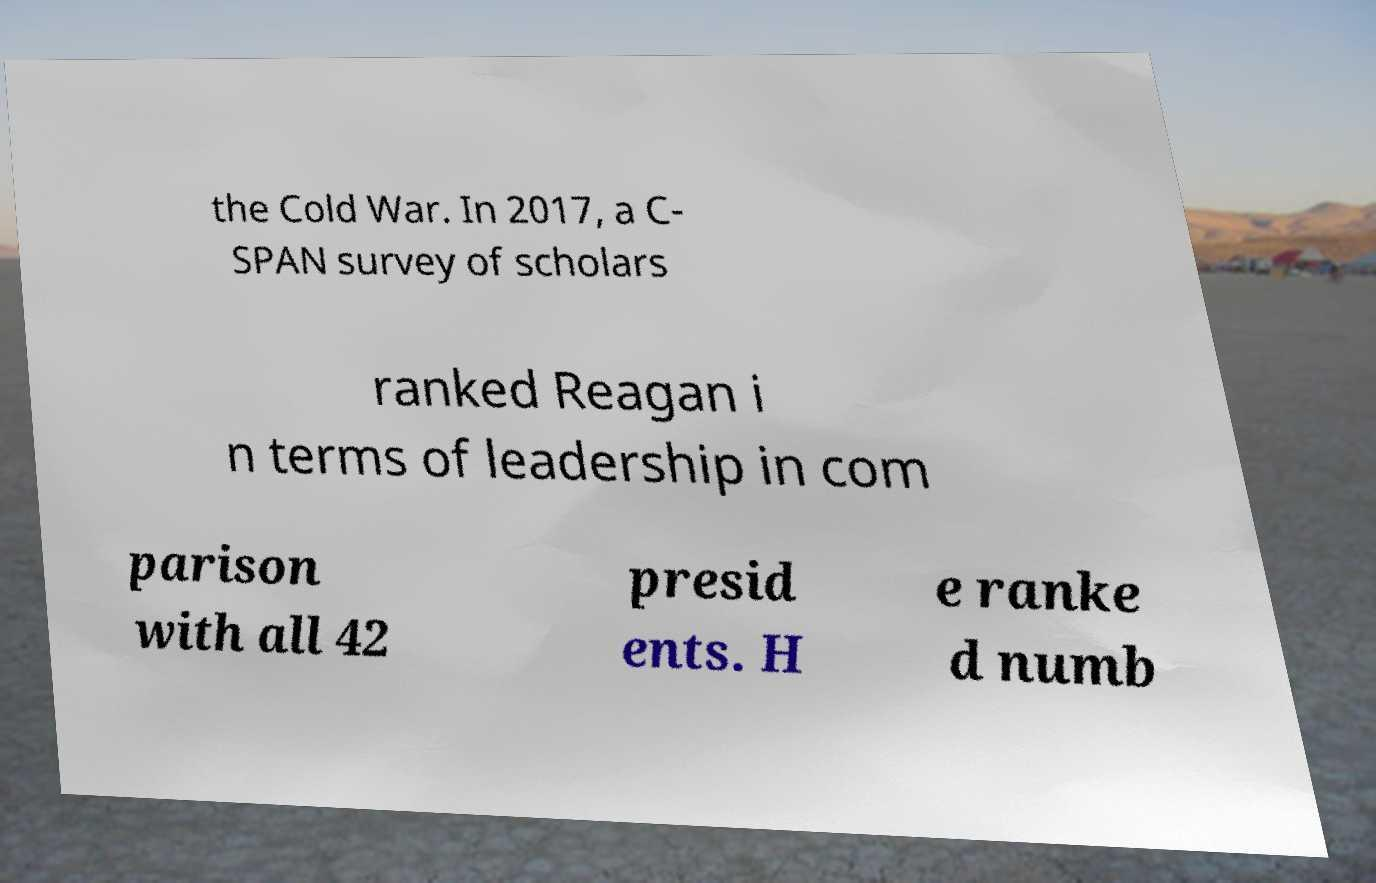What messages or text are displayed in this image? I need them in a readable, typed format. the Cold War. In 2017, a C- SPAN survey of scholars ranked Reagan i n terms of leadership in com parison with all 42 presid ents. H e ranke d numb 